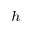<formula> <loc_0><loc_0><loc_500><loc_500>_ { h }</formula> 